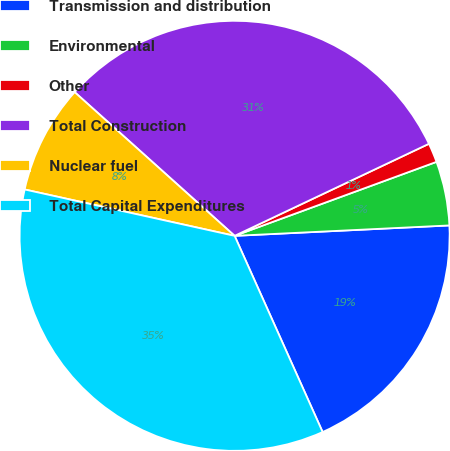<chart> <loc_0><loc_0><loc_500><loc_500><pie_chart><fcel>Transmission and distribution<fcel>Environmental<fcel>Other<fcel>Total Construction<fcel>Nuclear fuel<fcel>Total Capital Expenditures<nl><fcel>19.06%<fcel>4.82%<fcel>1.45%<fcel>31.31%<fcel>8.19%<fcel>35.17%<nl></chart> 